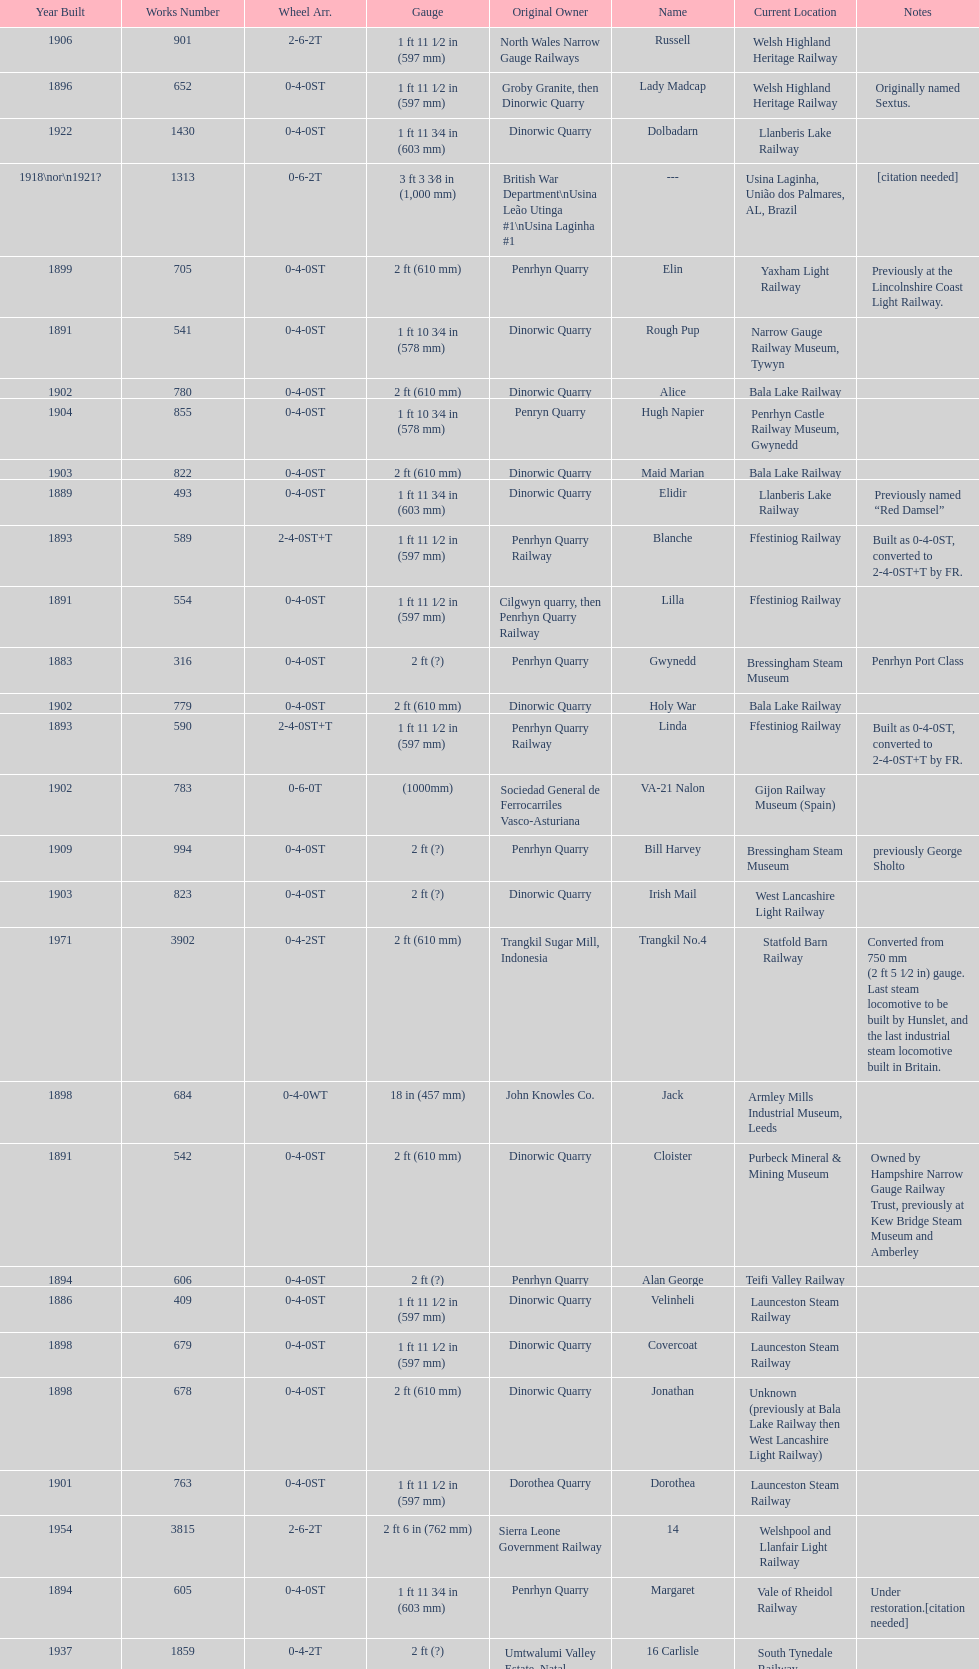After 1940, how many steam locomotives were built? 2. 